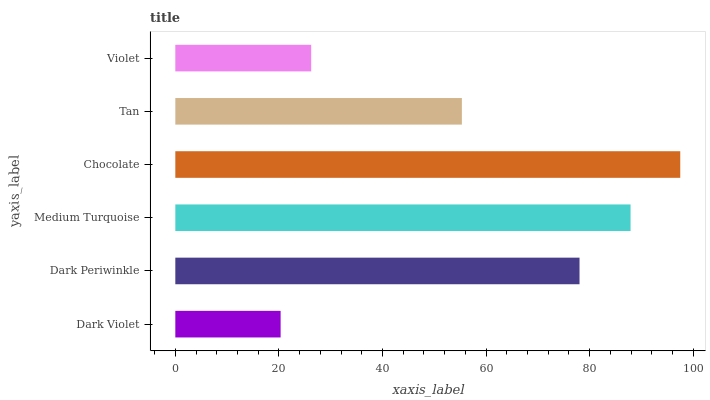Is Dark Violet the minimum?
Answer yes or no. Yes. Is Chocolate the maximum?
Answer yes or no. Yes. Is Dark Periwinkle the minimum?
Answer yes or no. No. Is Dark Periwinkle the maximum?
Answer yes or no. No. Is Dark Periwinkle greater than Dark Violet?
Answer yes or no. Yes. Is Dark Violet less than Dark Periwinkle?
Answer yes or no. Yes. Is Dark Violet greater than Dark Periwinkle?
Answer yes or no. No. Is Dark Periwinkle less than Dark Violet?
Answer yes or no. No. Is Dark Periwinkle the high median?
Answer yes or no. Yes. Is Tan the low median?
Answer yes or no. Yes. Is Dark Violet the high median?
Answer yes or no. No. Is Dark Violet the low median?
Answer yes or no. No. 